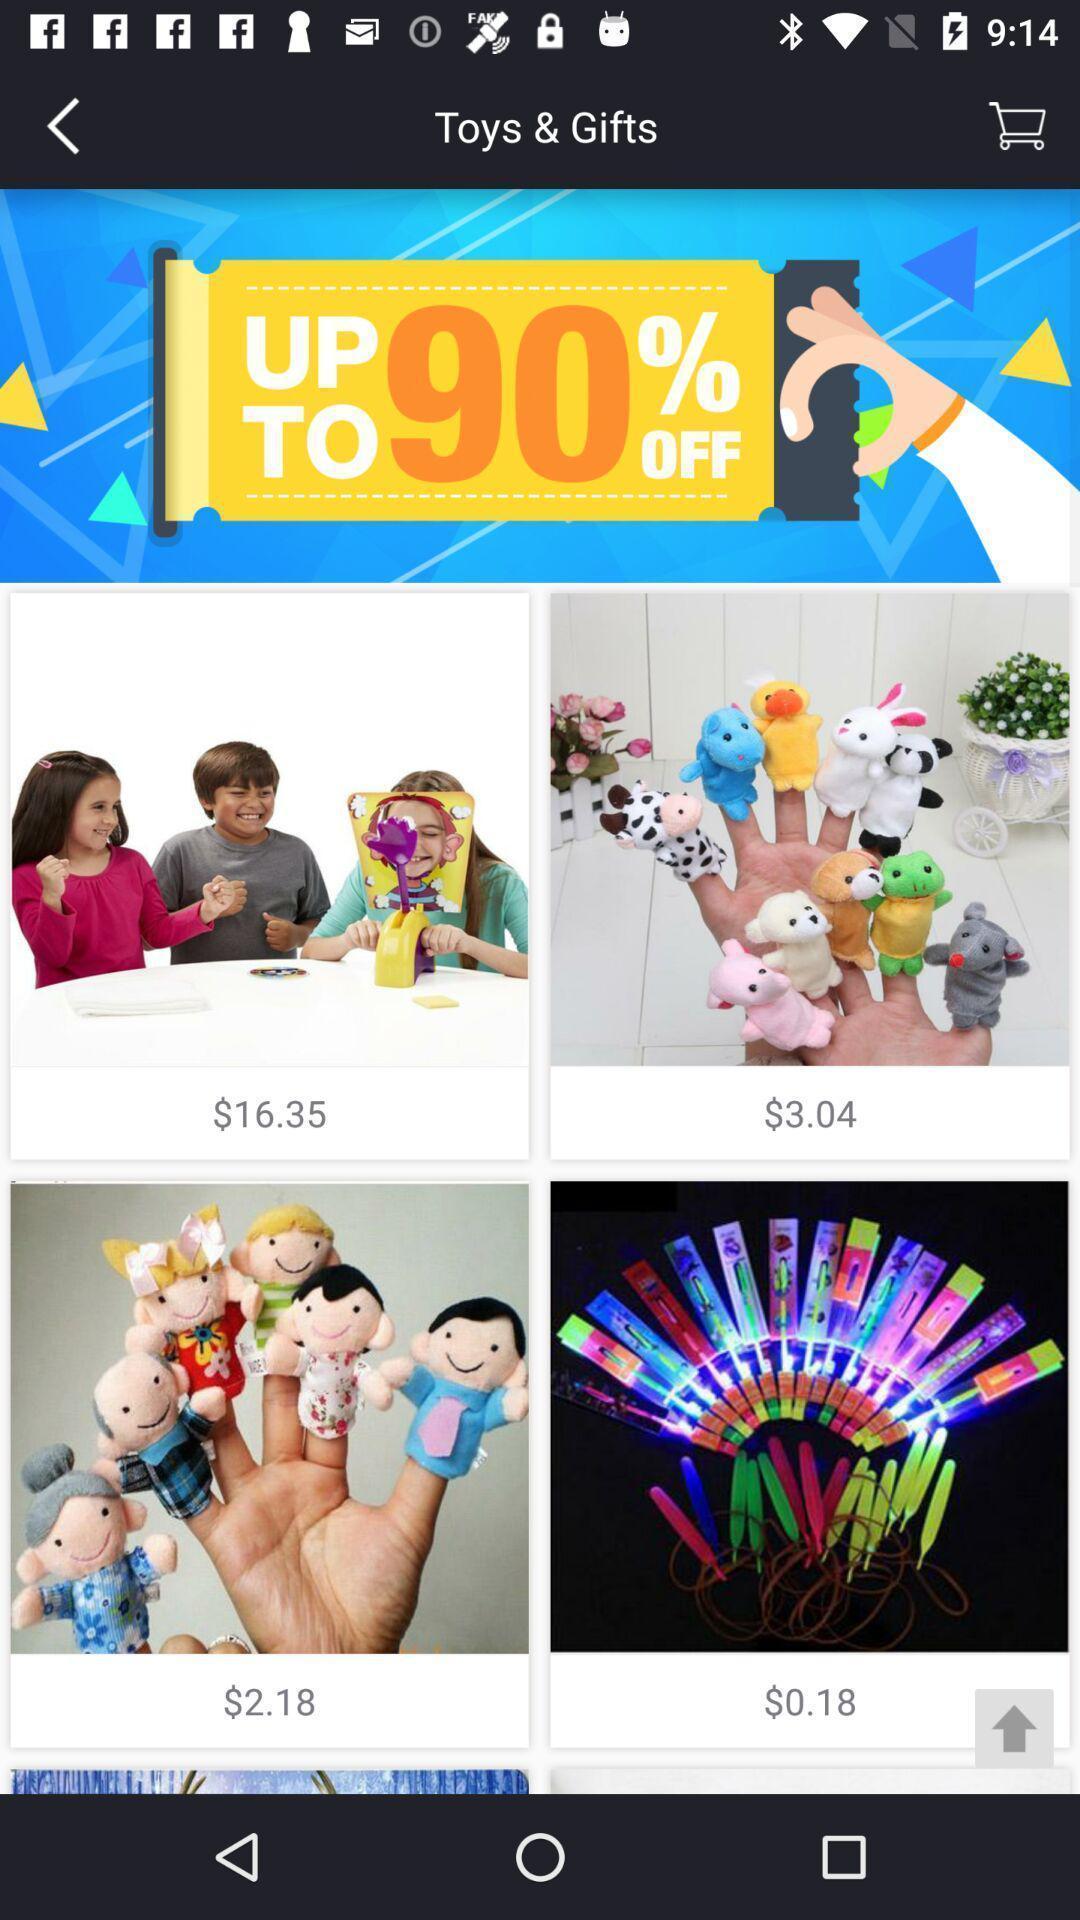Explain the elements present in this screenshot. Page displaying to purchase gifts of an shopping application. 